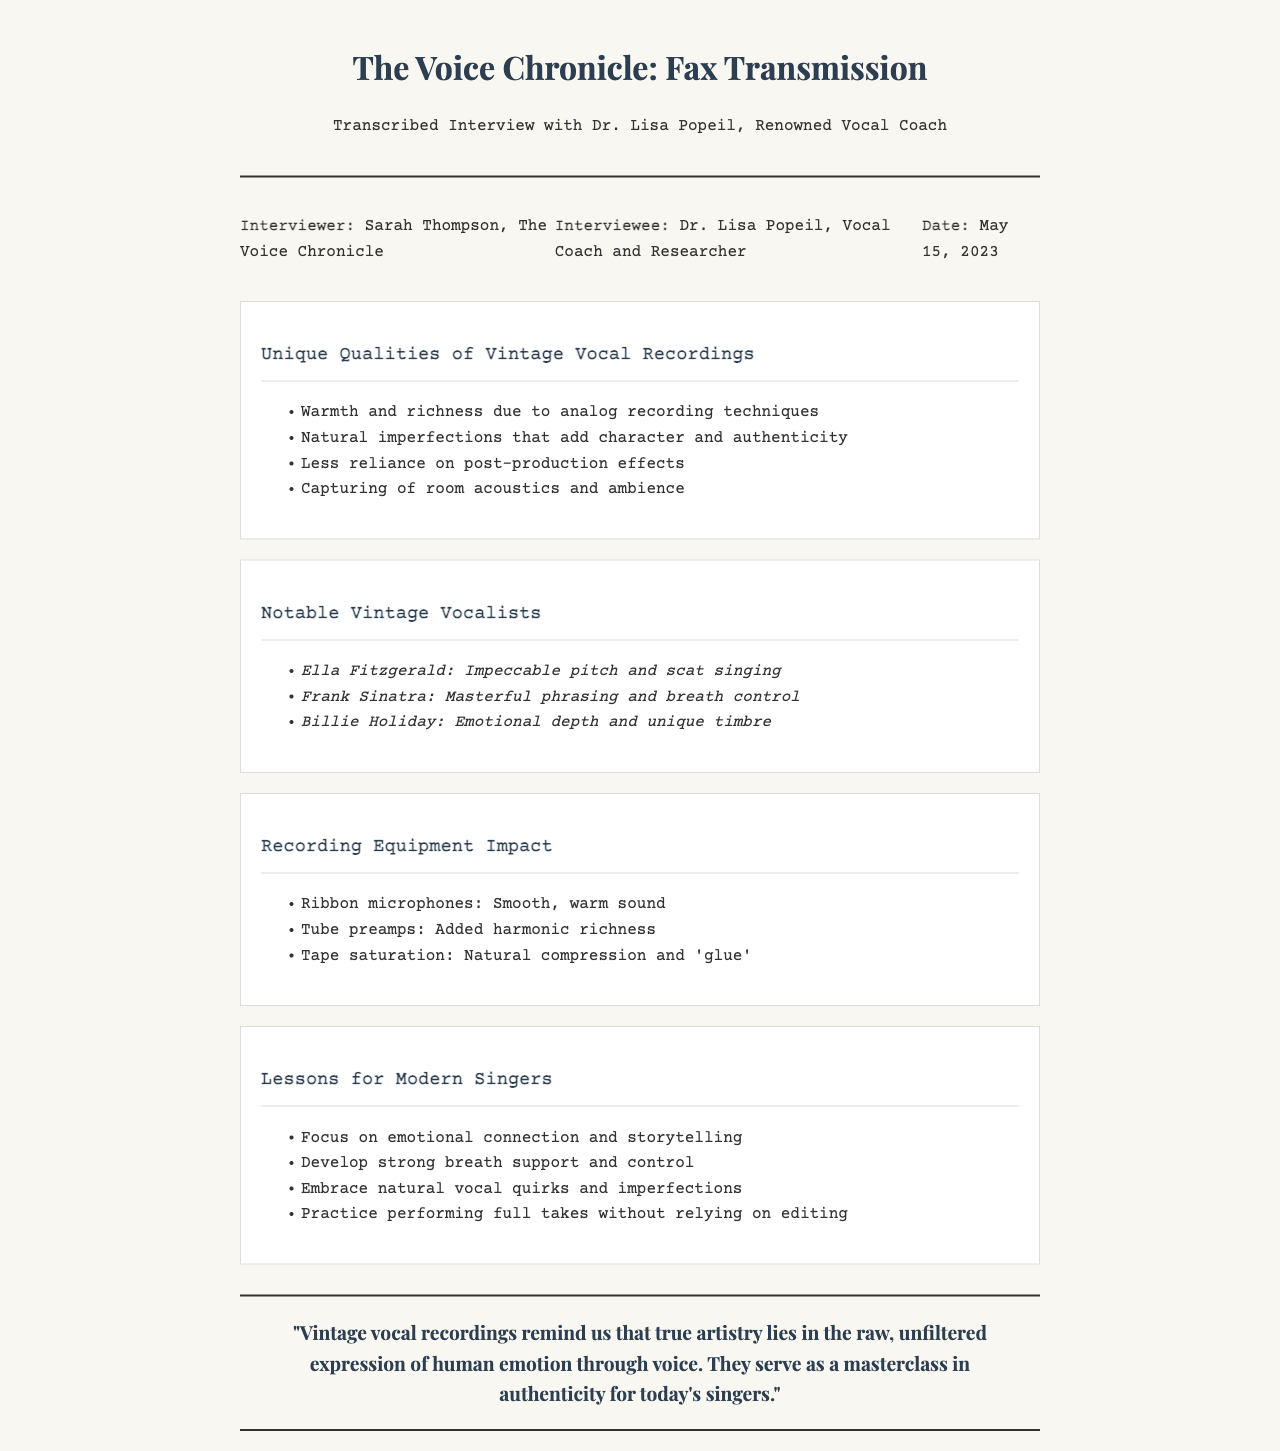What is the date of the interview? The date of the interview is mentioned in the document, which is May 15, 2023.
Answer: May 15, 2023 Who conducted the interview? The document states that the interviewer is Sarah Thompson, associated with The Voice Chronicle.
Answer: Sarah Thompson Name one unique quality of vintage vocal recordings. The document lists several unique qualities, including warmth and richness due to analog recording techniques.
Answer: Warmth and richness Which vocalists are noted as vintage examples? The interview highlights Ella Fitzgerald, Frank Sinatra, and Billie Holiday as notable vintage vocalists.
Answer: Ella Fitzgerald, Frank Sinatra, and Billie Holiday What type of microphones are mentioned for recording? The document specifies ribbon microphones as a type of recording equipment mentioned in the interview.
Answer: Ribbon microphones What lesson is emphasized for modern singers? One of the lessons for modern singers highlighted in the document is to focus on emotional connection and storytelling.
Answer: Focus on emotional connection and storytelling What is the title of the document? The title is given at the top of the fax, which is The Voice Chronicle: Fax Transmission.
Answer: The Voice Chronicle: Fax Transmission How many key points are there regarding unique qualities of vintage vocal recordings? The document lists four key points under that section regarding vintage vocal qualities.
Answer: Four 